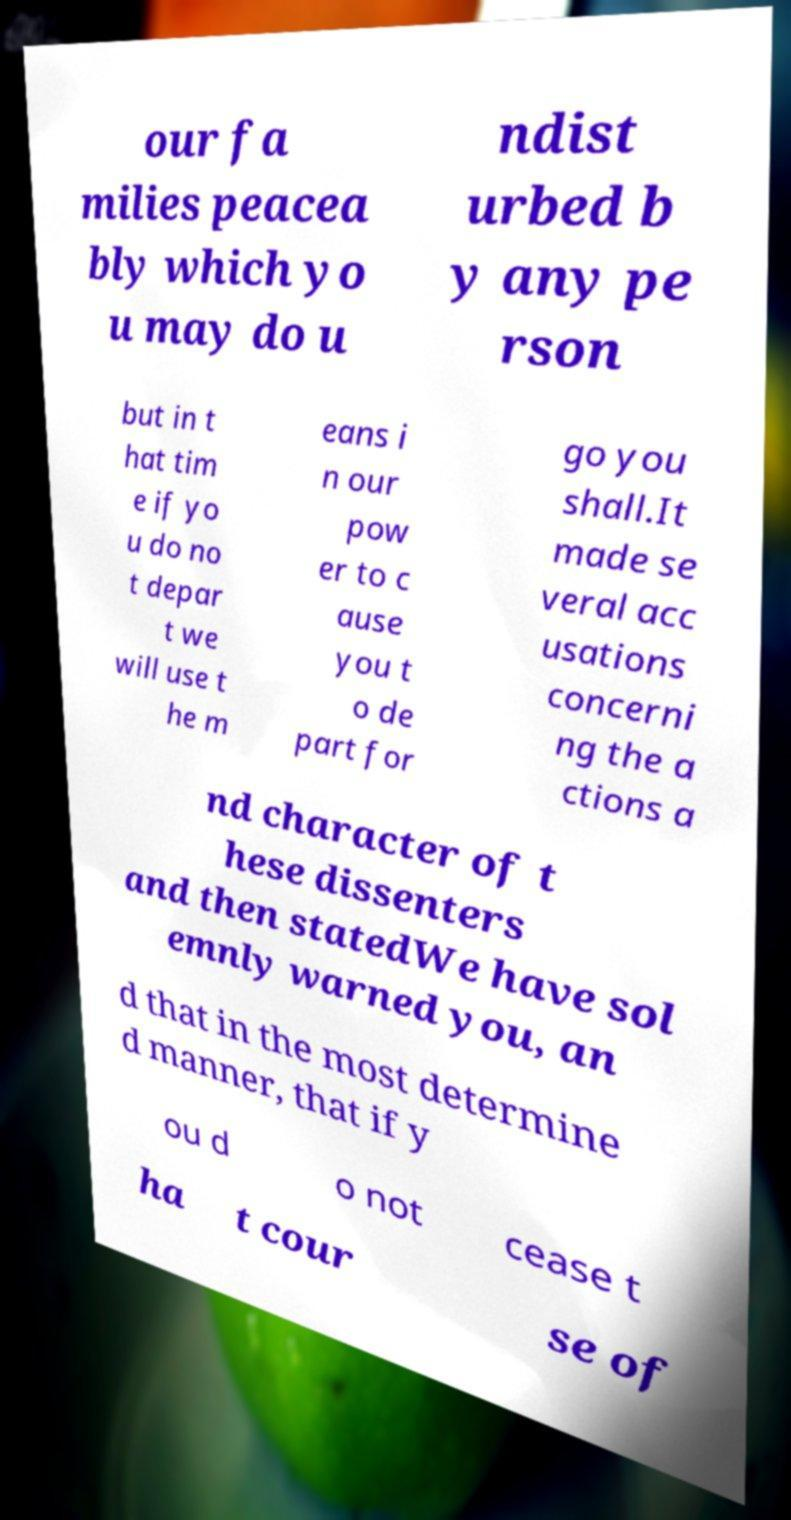Please read and relay the text visible in this image. What does it say? our fa milies peacea bly which yo u may do u ndist urbed b y any pe rson but in t hat tim e if yo u do no t depar t we will use t he m eans i n our pow er to c ause you t o de part for go you shall.It made se veral acc usations concerni ng the a ctions a nd character of t hese dissenters and then statedWe have sol emnly warned you, an d that in the most determine d manner, that if y ou d o not cease t ha t cour se of 